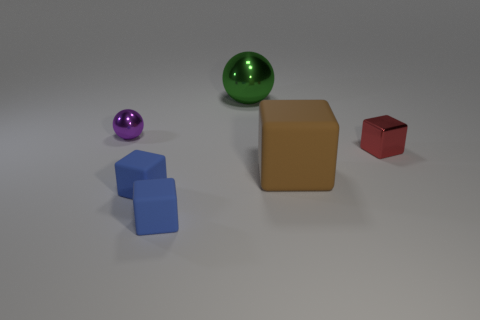There is a tiny metallic object that is on the left side of the tiny metal thing to the right of the small purple object; is there a metal sphere to the right of it?
Your answer should be very brief. Yes. There is a tiny metallic object right of the large rubber object; does it have the same color as the big rubber block?
Give a very brief answer. No. What number of cylinders are red shiny things or blue matte objects?
Provide a short and direct response. 0. The tiny shiny thing that is on the left side of the tiny shiny object to the right of the small purple ball is what shape?
Offer a very short reply. Sphere. There is a green metallic object on the left side of the small thing that is on the right side of the matte block that is to the right of the big green object; how big is it?
Your answer should be compact. Large. Is the size of the purple thing the same as the green metal object?
Give a very brief answer. No. How many objects are small rubber objects or purple things?
Provide a succinct answer. 3. There is a matte block that is on the right side of the large object behind the tiny red block; what is its size?
Make the answer very short. Large. The red metal cube is what size?
Your response must be concise. Small. There is a small thing that is right of the purple object and behind the big brown thing; what shape is it?
Give a very brief answer. Cube. 